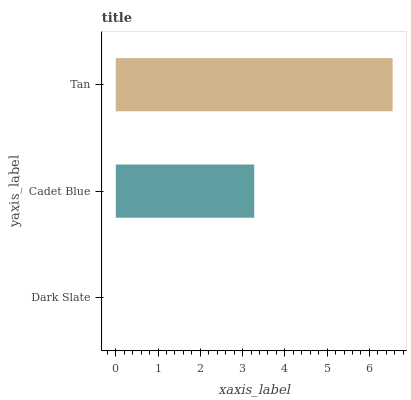Is Dark Slate the minimum?
Answer yes or no. Yes. Is Tan the maximum?
Answer yes or no. Yes. Is Cadet Blue the minimum?
Answer yes or no. No. Is Cadet Blue the maximum?
Answer yes or no. No. Is Cadet Blue greater than Dark Slate?
Answer yes or no. Yes. Is Dark Slate less than Cadet Blue?
Answer yes or no. Yes. Is Dark Slate greater than Cadet Blue?
Answer yes or no. No. Is Cadet Blue less than Dark Slate?
Answer yes or no. No. Is Cadet Blue the high median?
Answer yes or no. Yes. Is Cadet Blue the low median?
Answer yes or no. Yes. Is Dark Slate the high median?
Answer yes or no. No. Is Tan the low median?
Answer yes or no. No. 